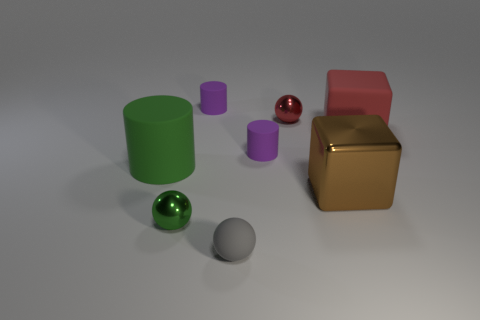What number of matte things are big yellow balls or tiny purple things?
Your response must be concise. 2. How many other things are the same shape as the brown shiny object?
Give a very brief answer. 1. Is the number of red rubber objects greater than the number of tiny red shiny cylinders?
Ensure brevity in your answer.  Yes. There is a object that is behind the small red object behind the matte cylinder that is to the right of the small gray rubber ball; what size is it?
Your answer should be very brief. Small. There is a purple rubber thing behind the large red object; how big is it?
Offer a terse response. Small. How many things are either small purple matte cylinders or small spheres that are behind the big cylinder?
Your answer should be compact. 3. How many other objects are there of the same size as the green metallic sphere?
Provide a short and direct response. 4. There is a tiny green thing that is the same shape as the gray object; what is it made of?
Offer a terse response. Metal. Is the number of tiny green metallic spheres to the right of the brown block greater than the number of small purple cylinders?
Keep it short and to the point. No. Is there any other thing of the same color as the rubber ball?
Make the answer very short. No. 